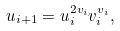Convert formula to latex. <formula><loc_0><loc_0><loc_500><loc_500>u _ { i + 1 } = u _ { i } ^ { 2 v _ { i } } v _ { i } ^ { v _ { i } } ,</formula> 